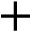<formula> <loc_0><loc_0><loc_500><loc_500>+</formula> 